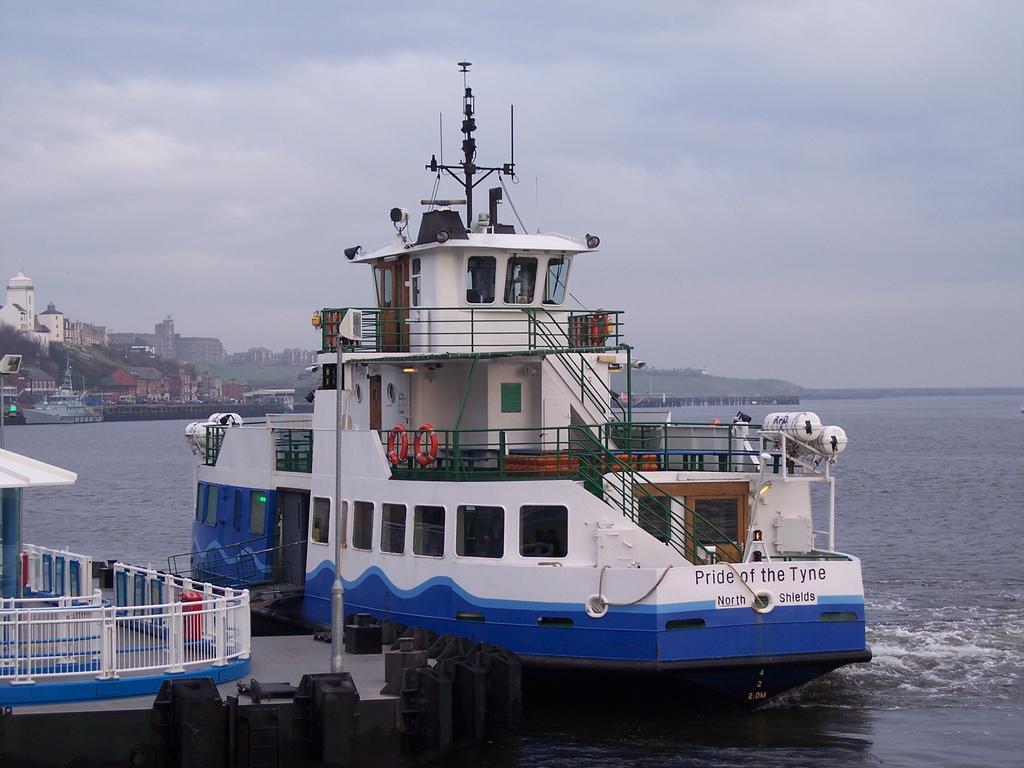Could you give a brief overview of what you see in this image? To the left side of the image there is a path with white color railings. In front of that there is a big ship with white and blue color. And on the ship there are swimming tubes, railing, steps, poles and few other items on it. And the ship is on the water. To the right side there is a water. To the left side background there are many buildings and also there are ships. To the top of the image there is a sky. 